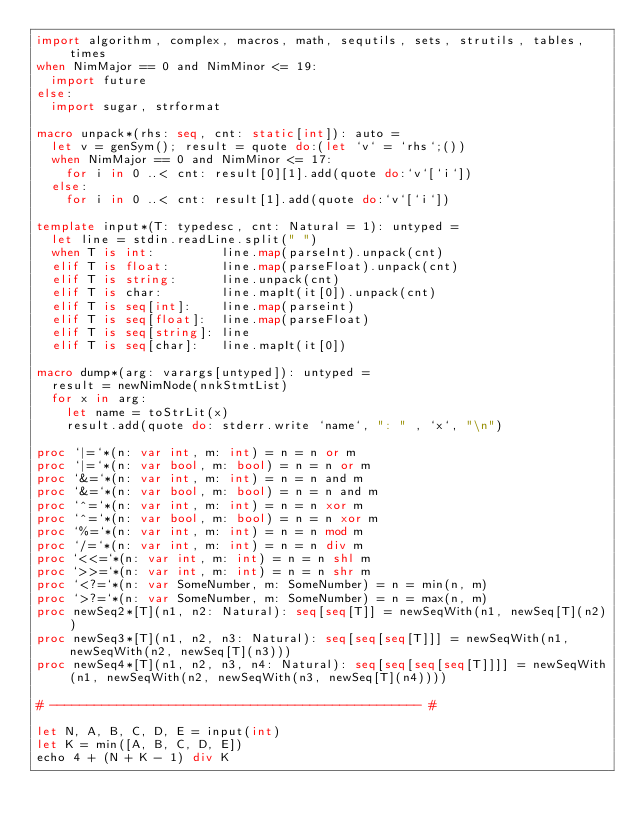Convert code to text. <code><loc_0><loc_0><loc_500><loc_500><_Nim_>import algorithm, complex, macros, math, sequtils, sets, strutils, tables, times
when NimMajor == 0 and NimMinor <= 19:
  import future
else:
  import sugar, strformat

macro unpack*(rhs: seq, cnt: static[int]): auto =
  let v = genSym(); result = quote do:(let `v` = `rhs`;())
  when NimMajor == 0 and NimMinor <= 17:
    for i in 0 ..< cnt: result[0][1].add(quote do:`v`[`i`])
  else:
    for i in 0 ..< cnt: result[1].add(quote do:`v`[`i`])

template input*(T: typedesc, cnt: Natural = 1): untyped =
  let line = stdin.readLine.split(" ")
  when T is int:         line.map(parseInt).unpack(cnt)
  elif T is float:       line.map(parseFloat).unpack(cnt)
  elif T is string:      line.unpack(cnt)
  elif T is char:        line.mapIt(it[0]).unpack(cnt)
  elif T is seq[int]:    line.map(parseint)
  elif T is seq[float]:  line.map(parseFloat)
  elif T is seq[string]: line
  elif T is seq[char]:   line.mapIt(it[0])

macro dump*(arg: varargs[untyped]): untyped =
  result = newNimNode(nnkStmtList)
  for x in arg:
    let name = toStrLit(x)
    result.add(quote do: stderr.write `name`, ": " , `x`, "\n")

proc `|=`*(n: var int, m: int) = n = n or m
proc `|=`*(n: var bool, m: bool) = n = n or m
proc `&=`*(n: var int, m: int) = n = n and m
proc `&=`*(n: var bool, m: bool) = n = n and m
proc `^=`*(n: var int, m: int) = n = n xor m
proc `^=`*(n: var bool, m: bool) = n = n xor m
proc `%=`*(n: var int, m: int) = n = n mod m
proc `/=`*(n: var int, m: int) = n = n div m
proc `<<=`*(n: var int, m: int) = n = n shl m
proc `>>=`*(n: var int, m: int) = n = n shr m
proc `<?=`*(n: var SomeNumber, m: SomeNumber) = n = min(n, m)
proc `>?=`*(n: var SomeNumber, m: SomeNumber) = n = max(n, m)
proc newSeq2*[T](n1, n2: Natural): seq[seq[T]] = newSeqWith(n1, newSeq[T](n2))
proc newSeq3*[T](n1, n2, n3: Natural): seq[seq[seq[T]]] = newSeqWith(n1, newSeqWith(n2, newSeq[T](n3)))
proc newSeq4*[T](n1, n2, n3, n4: Natural): seq[seq[seq[seq[T]]]] = newSeqWith(n1, newSeqWith(n2, newSeqWith(n3, newSeq[T](n4))))

# -------------------------------------------------- #

let N, A, B, C, D, E = input(int)
let K = min([A, B, C, D, E])
echo 4 + (N + K - 1) div K</code> 